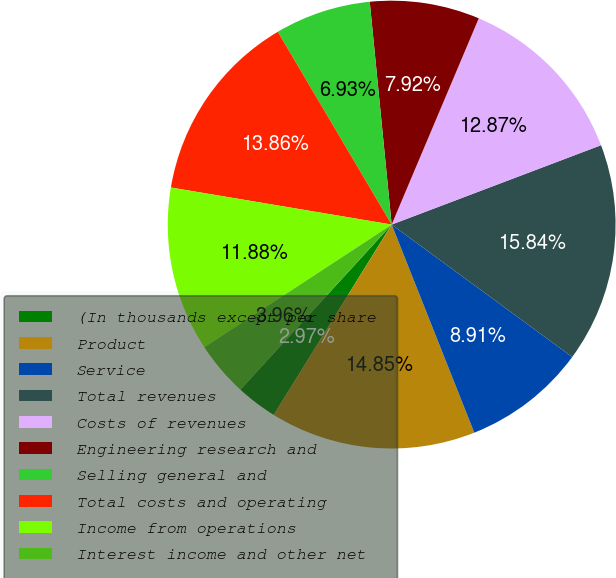<chart> <loc_0><loc_0><loc_500><loc_500><pie_chart><fcel>(In thousands except per share<fcel>Product<fcel>Service<fcel>Total revenues<fcel>Costs of revenues<fcel>Engineering research and<fcel>Selling general and<fcel>Total costs and operating<fcel>Income from operations<fcel>Interest income and other net<nl><fcel>2.97%<fcel>14.85%<fcel>8.91%<fcel>15.84%<fcel>12.87%<fcel>7.92%<fcel>6.93%<fcel>13.86%<fcel>11.88%<fcel>3.96%<nl></chart> 